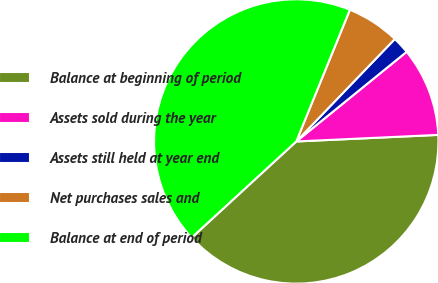Convert chart to OTSL. <chart><loc_0><loc_0><loc_500><loc_500><pie_chart><fcel>Balance at beginning of period<fcel>Assets sold during the year<fcel>Assets still held at year end<fcel>Net purchases sales and<fcel>Balance at end of period<nl><fcel>38.9%<fcel>10.12%<fcel>1.95%<fcel>6.04%<fcel>42.98%<nl></chart> 